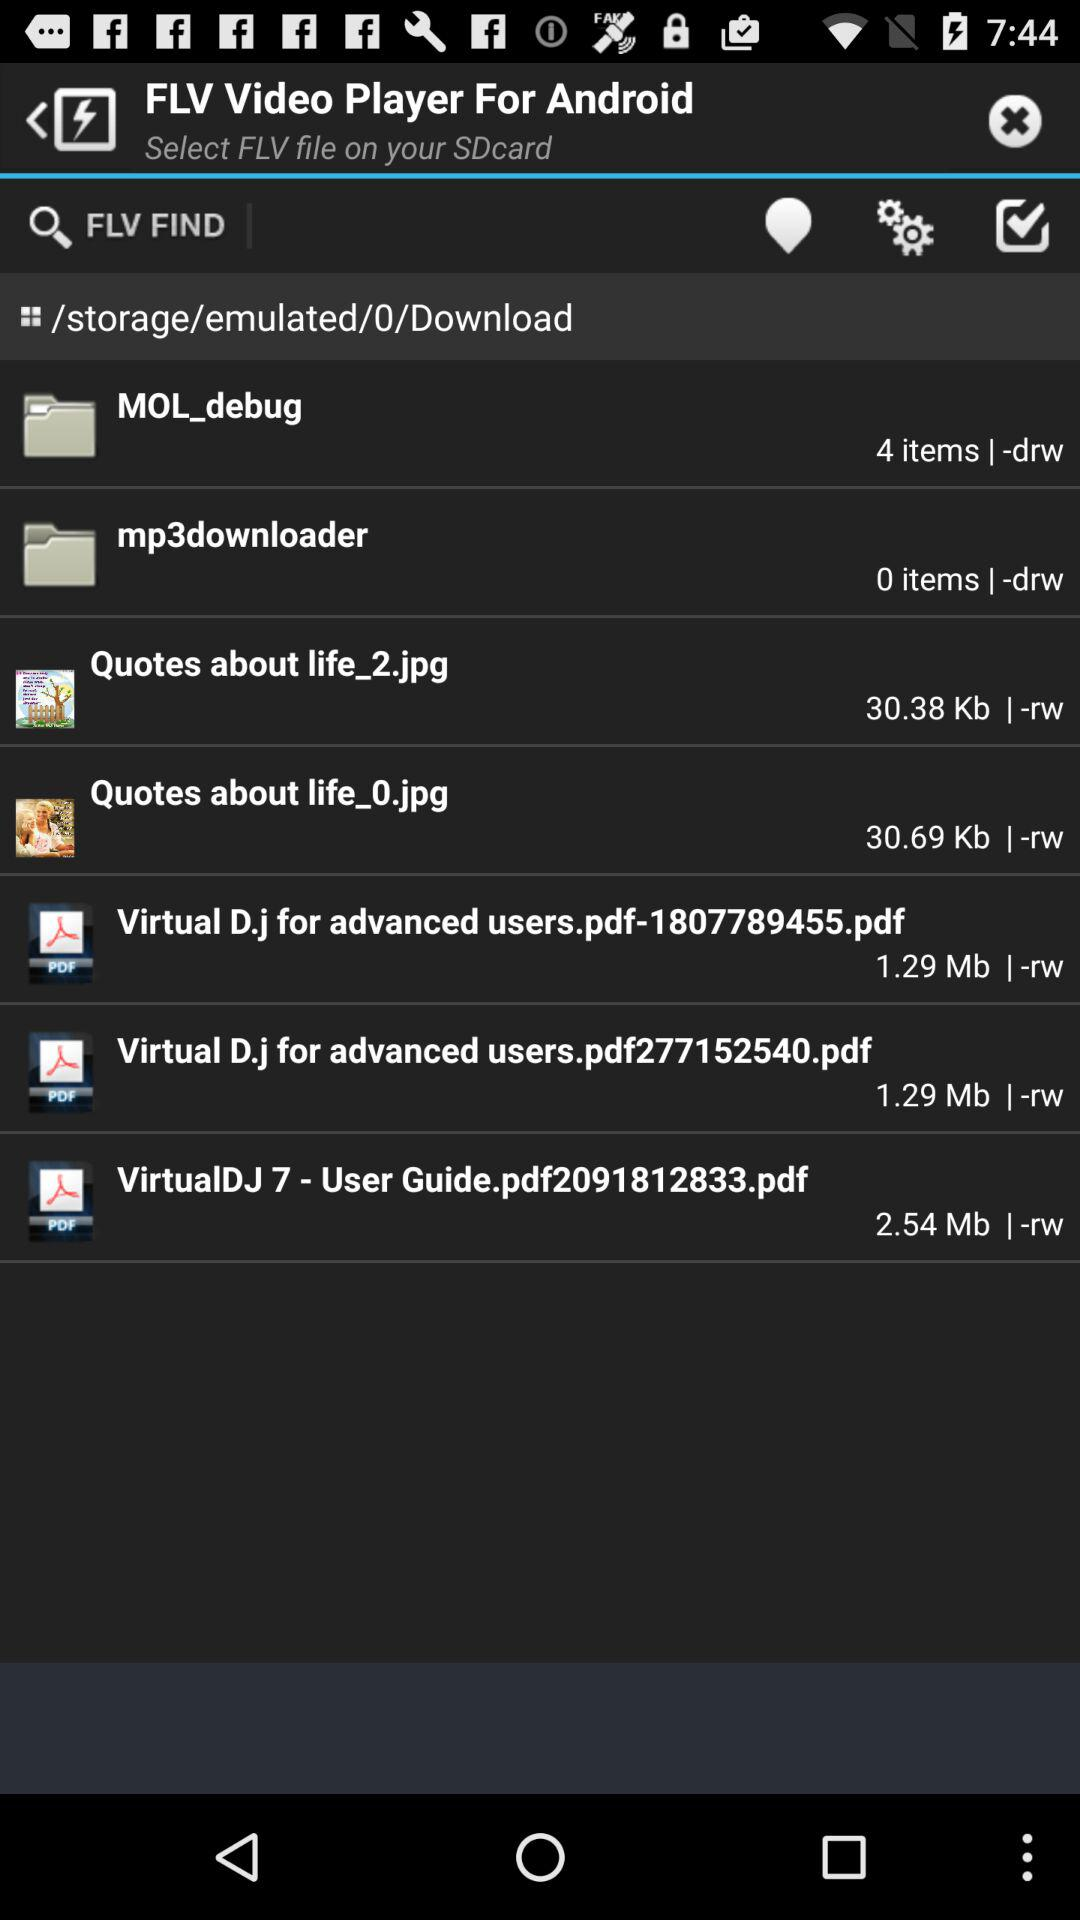How many kilobytes does "mp3downloader" have?
When the provided information is insufficient, respond with <no answer>. <no answer> 